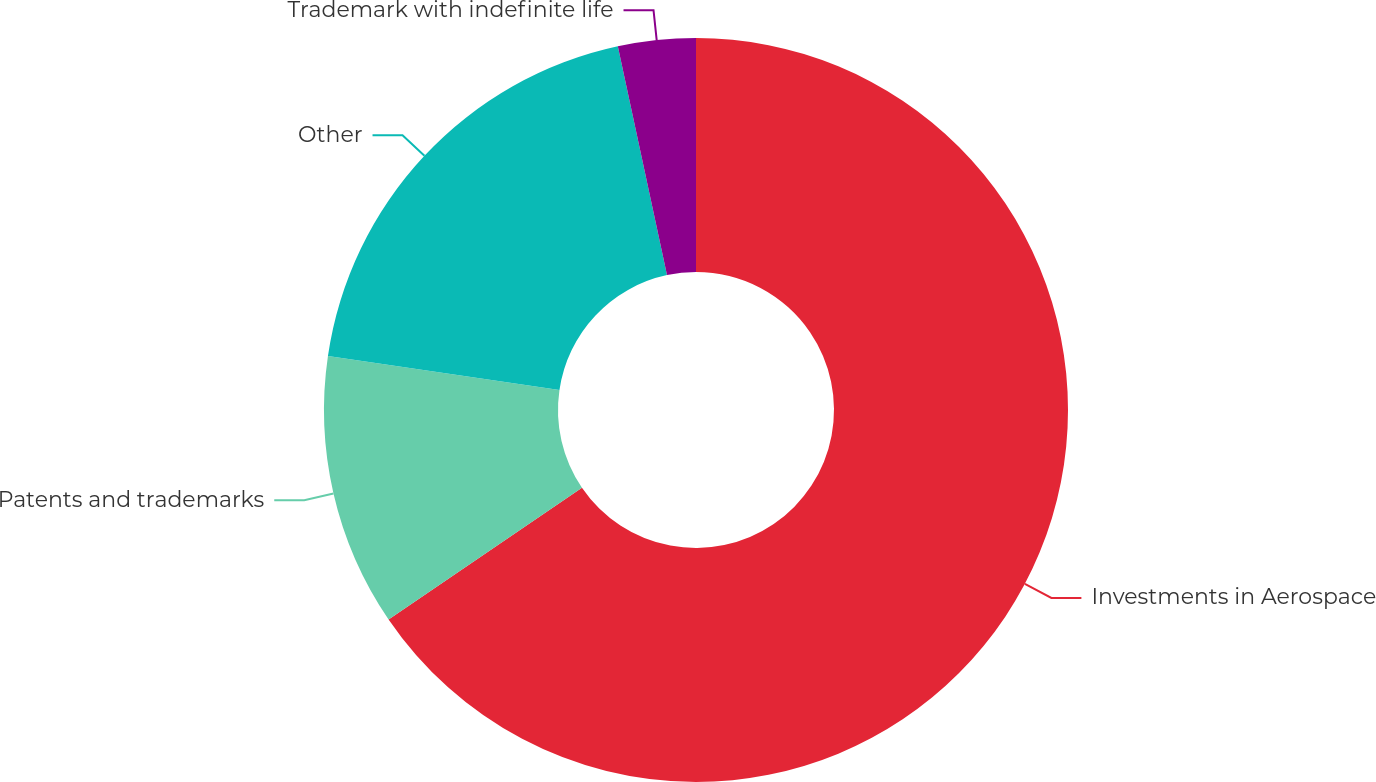Convert chart to OTSL. <chart><loc_0><loc_0><loc_500><loc_500><pie_chart><fcel>Investments in Aerospace<fcel>Patents and trademarks<fcel>Other<fcel>Trademark with indefinite life<nl><fcel>65.48%<fcel>11.84%<fcel>19.31%<fcel>3.37%<nl></chart> 